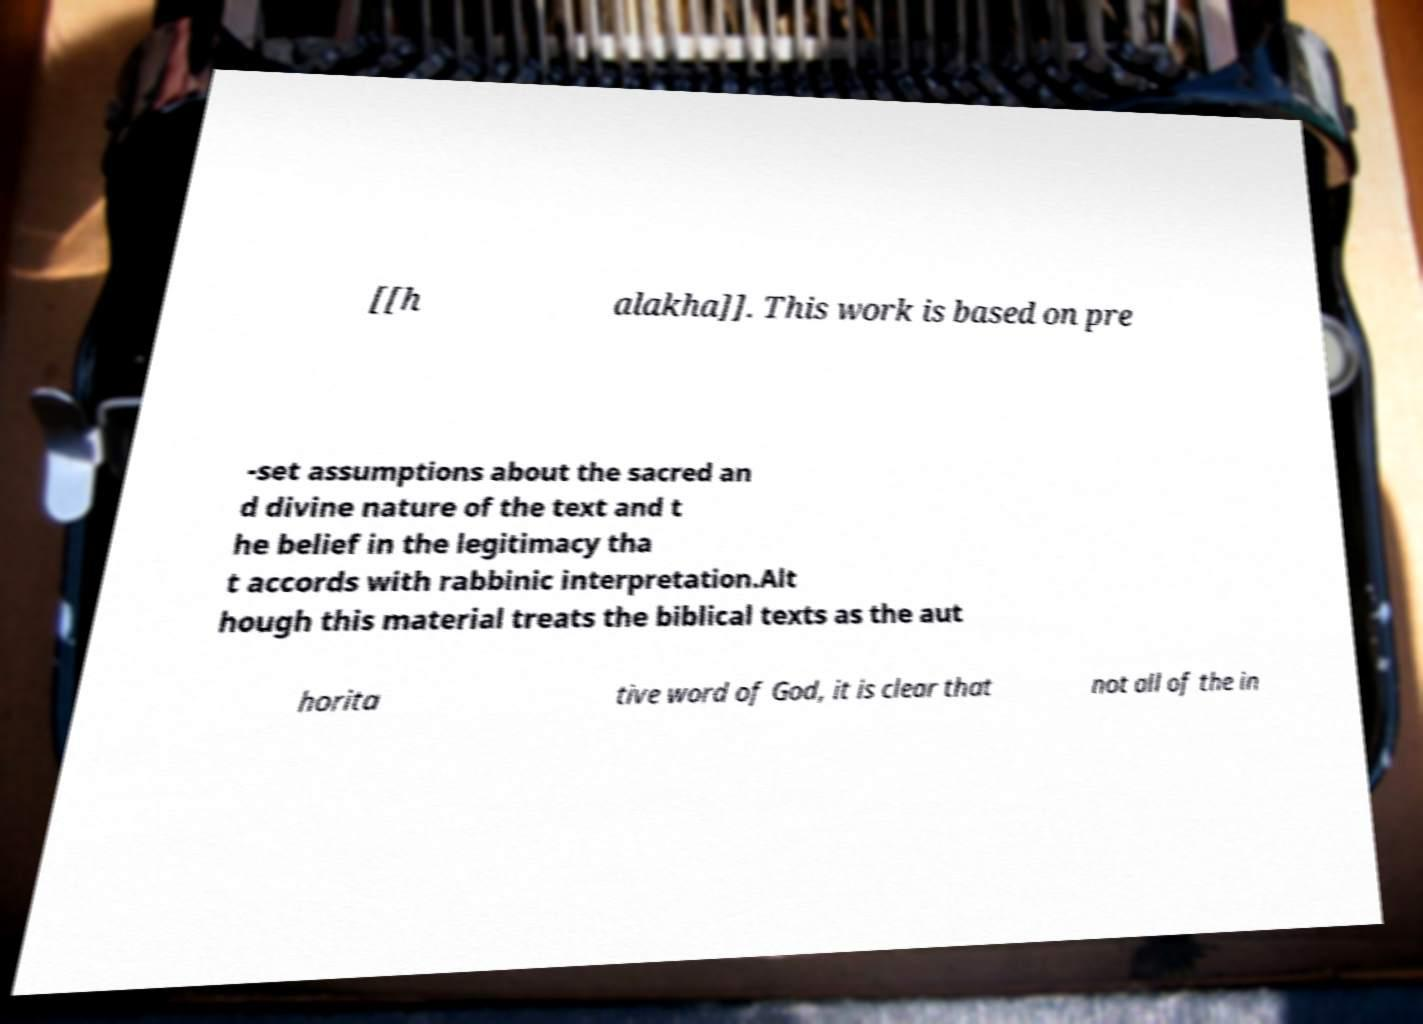Please read and relay the text visible in this image. What does it say? [[h alakha]]. This work is based on pre -set assumptions about the sacred an d divine nature of the text and t he belief in the legitimacy tha t accords with rabbinic interpretation.Alt hough this material treats the biblical texts as the aut horita tive word of God, it is clear that not all of the in 